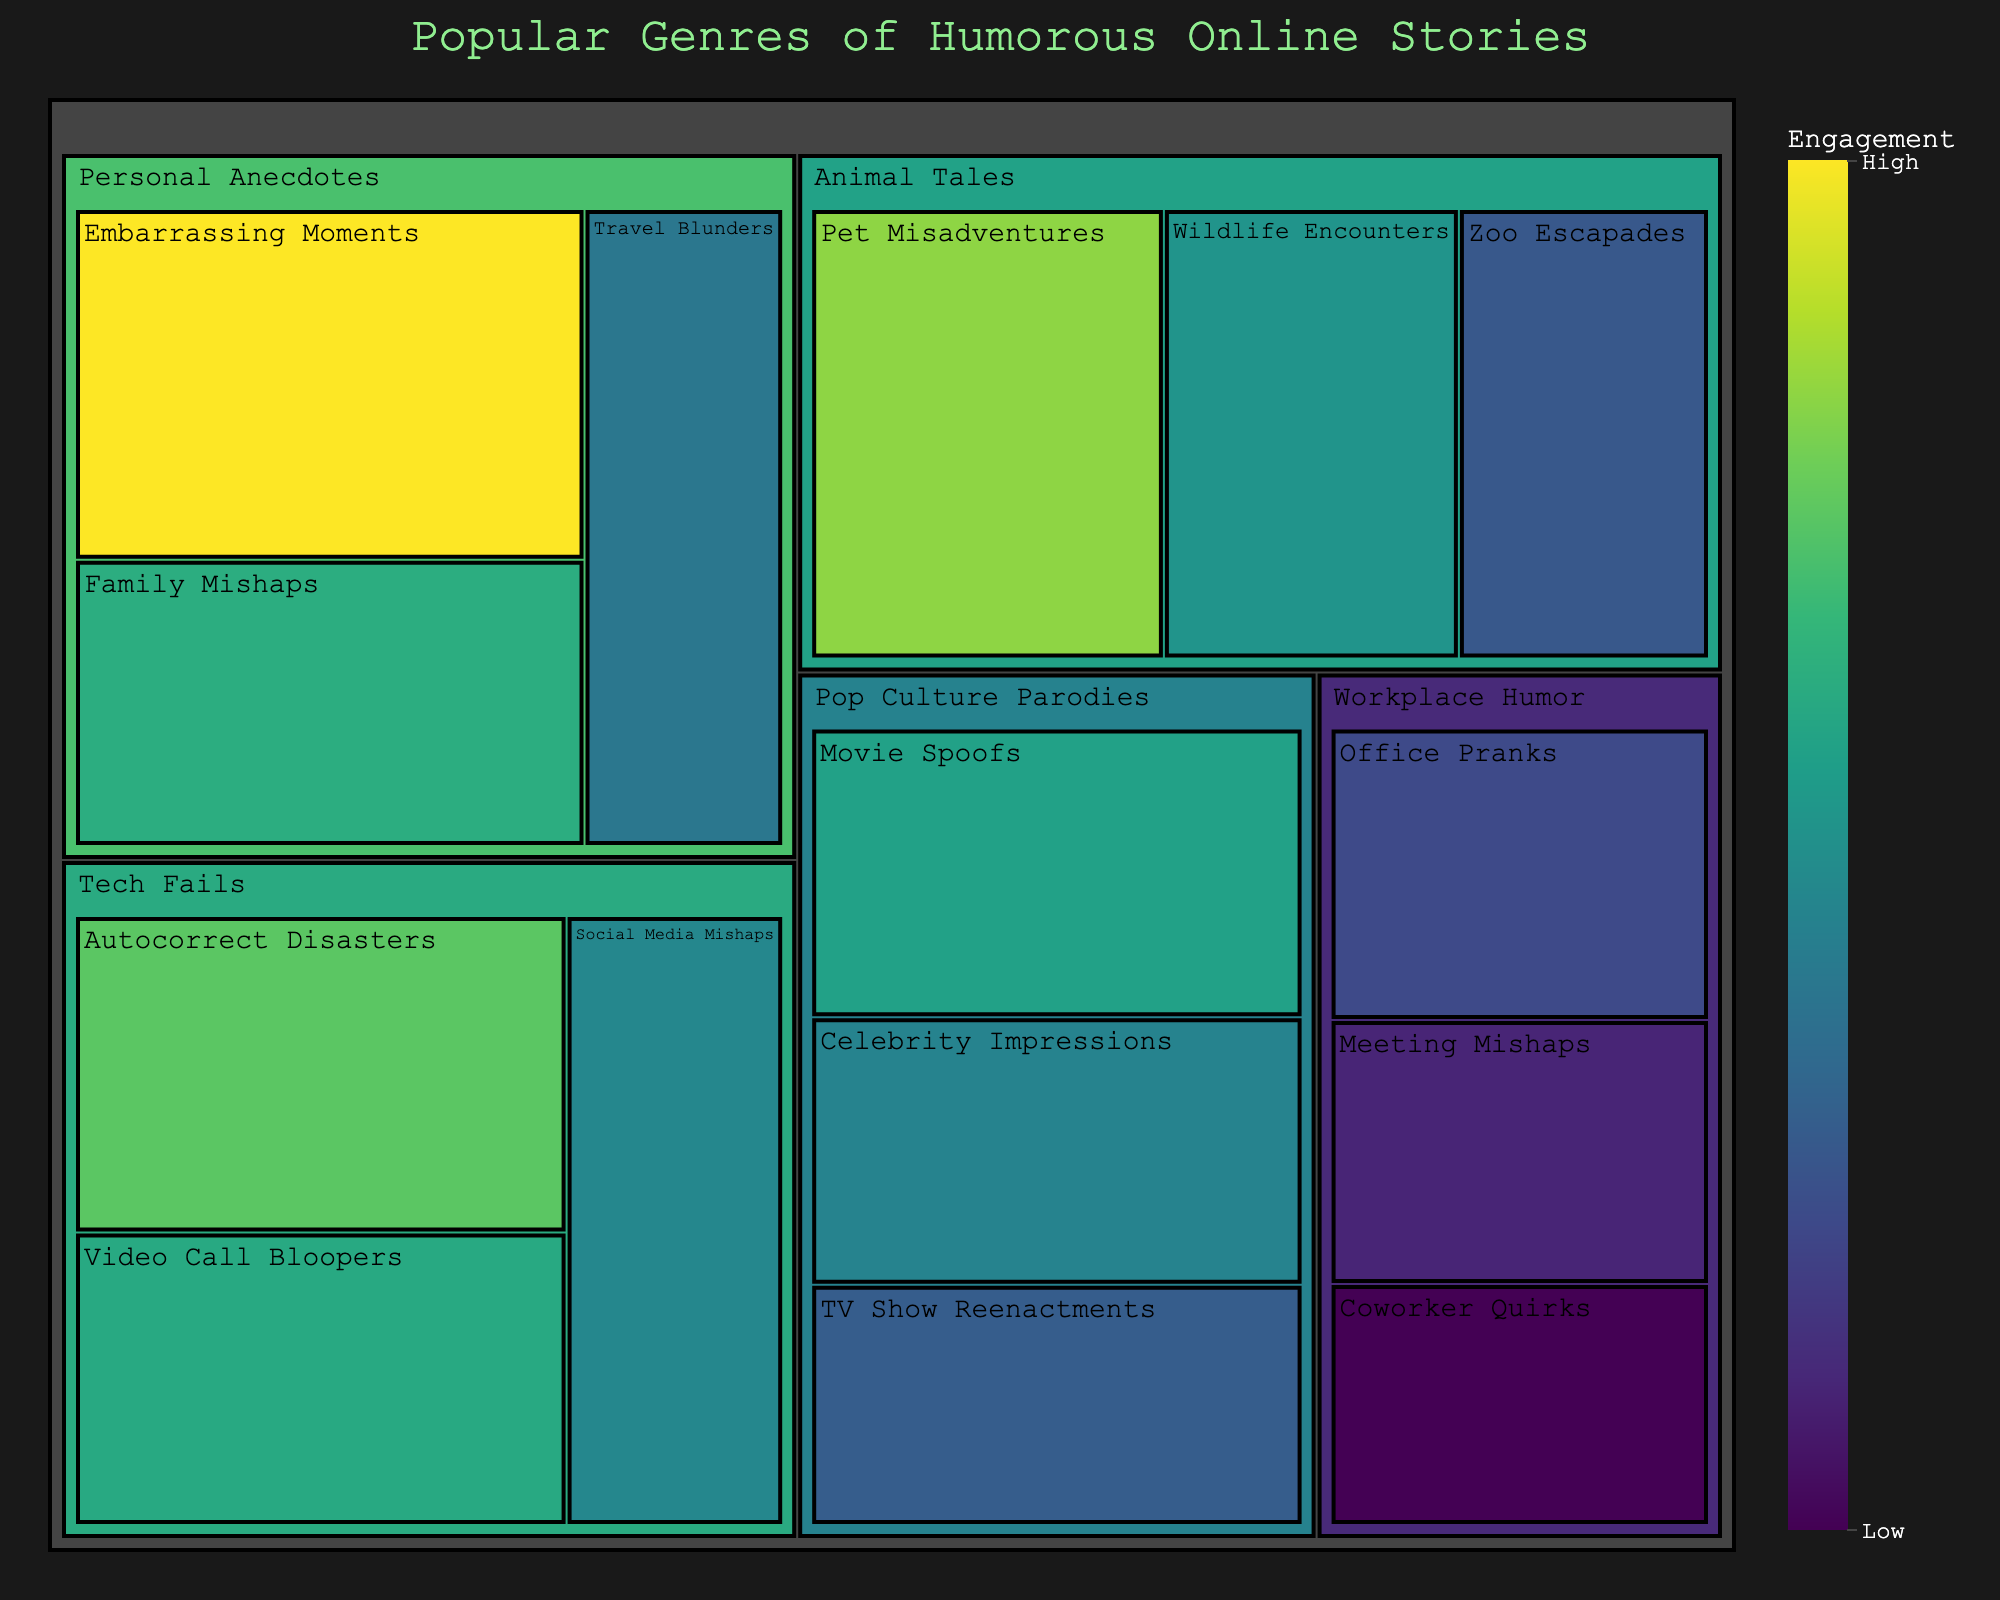What's the title of the treemap? The title is displayed at the top center of the treemap. It summarizes what the treemap is about.
Answer: Popular Genres of Humorous Online Stories Which subcategory has the highest engagement in the 'Personal Anecdotes' category? Look for the largest box within the 'Personal Anecdotes' category. The size and label indicate the engagement level.
Answer: Embarrassing Moments What is the engagement for 'Autocorrect Disasters' in the 'Tech Fails' category? Locate 'Tech Fails' and then find the box labeled 'Autocorrect Disasters'. The size and the engagement value displayed will give the answer.
Answer: 1050 Compare the engagement of 'Pet Misadventures' to 'Wildlife Encounters' under 'Animal Tales'. Which one is greater? Locate both subcategories under 'Animal Tales' and compare their sizes or engagement values.
Answer: Pet Misadventures What is the total engagement of all subcategories in 'Workplace Humor'? Sum the engagement values of 'Office Pranks', 'Meeting Mishaps', and 'Coworker Quirks'.
Answer: 750 + 680 + 620 = 2050 Which subcategory within 'Pop Culture Parodies' has the least engagement? Look for the smallest box in the 'Pop Culture Parodies' category or compare the engagement values.
Answer: TV Show Reenactments What is the average engagement for the subcategories in 'Tech Fails'? Sum the engagement values for 'Autocorrect Disasters', 'Video Call Bloopers', and 'Social Media Mishaps', and then divide by 3.
Answer: (1050 + 970 + 890) / 3 = 970 Is 'Zoo Escapades' more or less popular than 'Movie Spoofs'? Compare their sizes or the engagement values directly.
Answer: Less popular How many subcategories are there in total across all categories? Count the number of unique subcategories shown in the treemap.
Answer: 12 What is the engagement difference between 'Travel Blunders' and 'Zoo Escapades'? Find the engagement values for both and subtract the smaller from the larger.
Answer: 850 - 780 = 70 